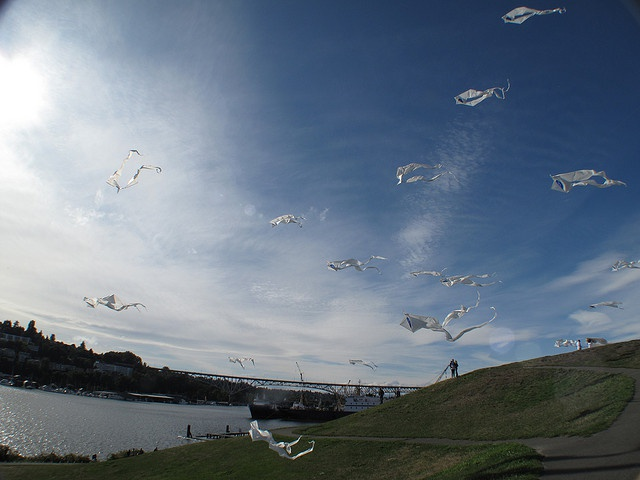Describe the objects in this image and their specific colors. I can see boat in black, gray, and darkgray tones, kite in black, darkgray, and gray tones, kite in black, gray, and darkgray tones, kite in black, gray, blue, and darkgray tones, and kite in black, gray, and darkgray tones in this image. 